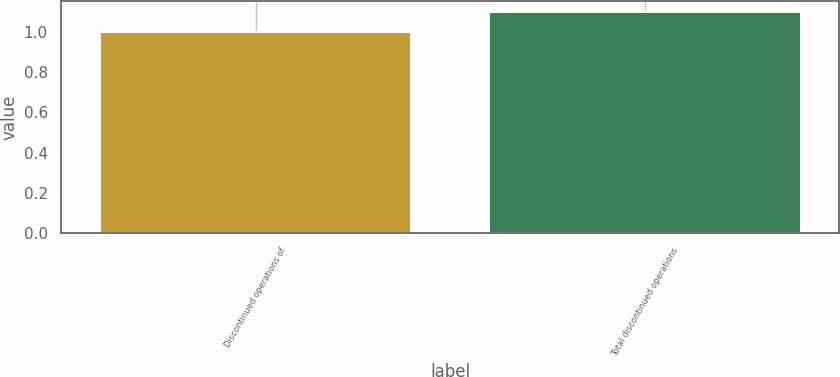<chart> <loc_0><loc_0><loc_500><loc_500><bar_chart><fcel>Discontinued operations of<fcel>Total discontinued operations<nl><fcel>1<fcel>1.1<nl></chart> 